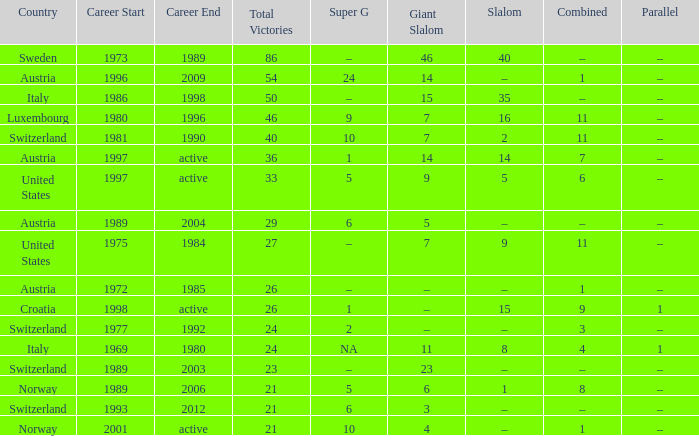What Career has a Super G of 5, and a Combined of 6? 1997–active. 